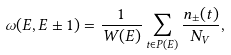Convert formula to latex. <formula><loc_0><loc_0><loc_500><loc_500>\omega ( E , E \pm 1 ) = \frac { 1 } { W ( E ) } \sum _ { t \in P ( E ) } \frac { n _ { \pm } ( t ) } { N _ { V } } ,</formula> 